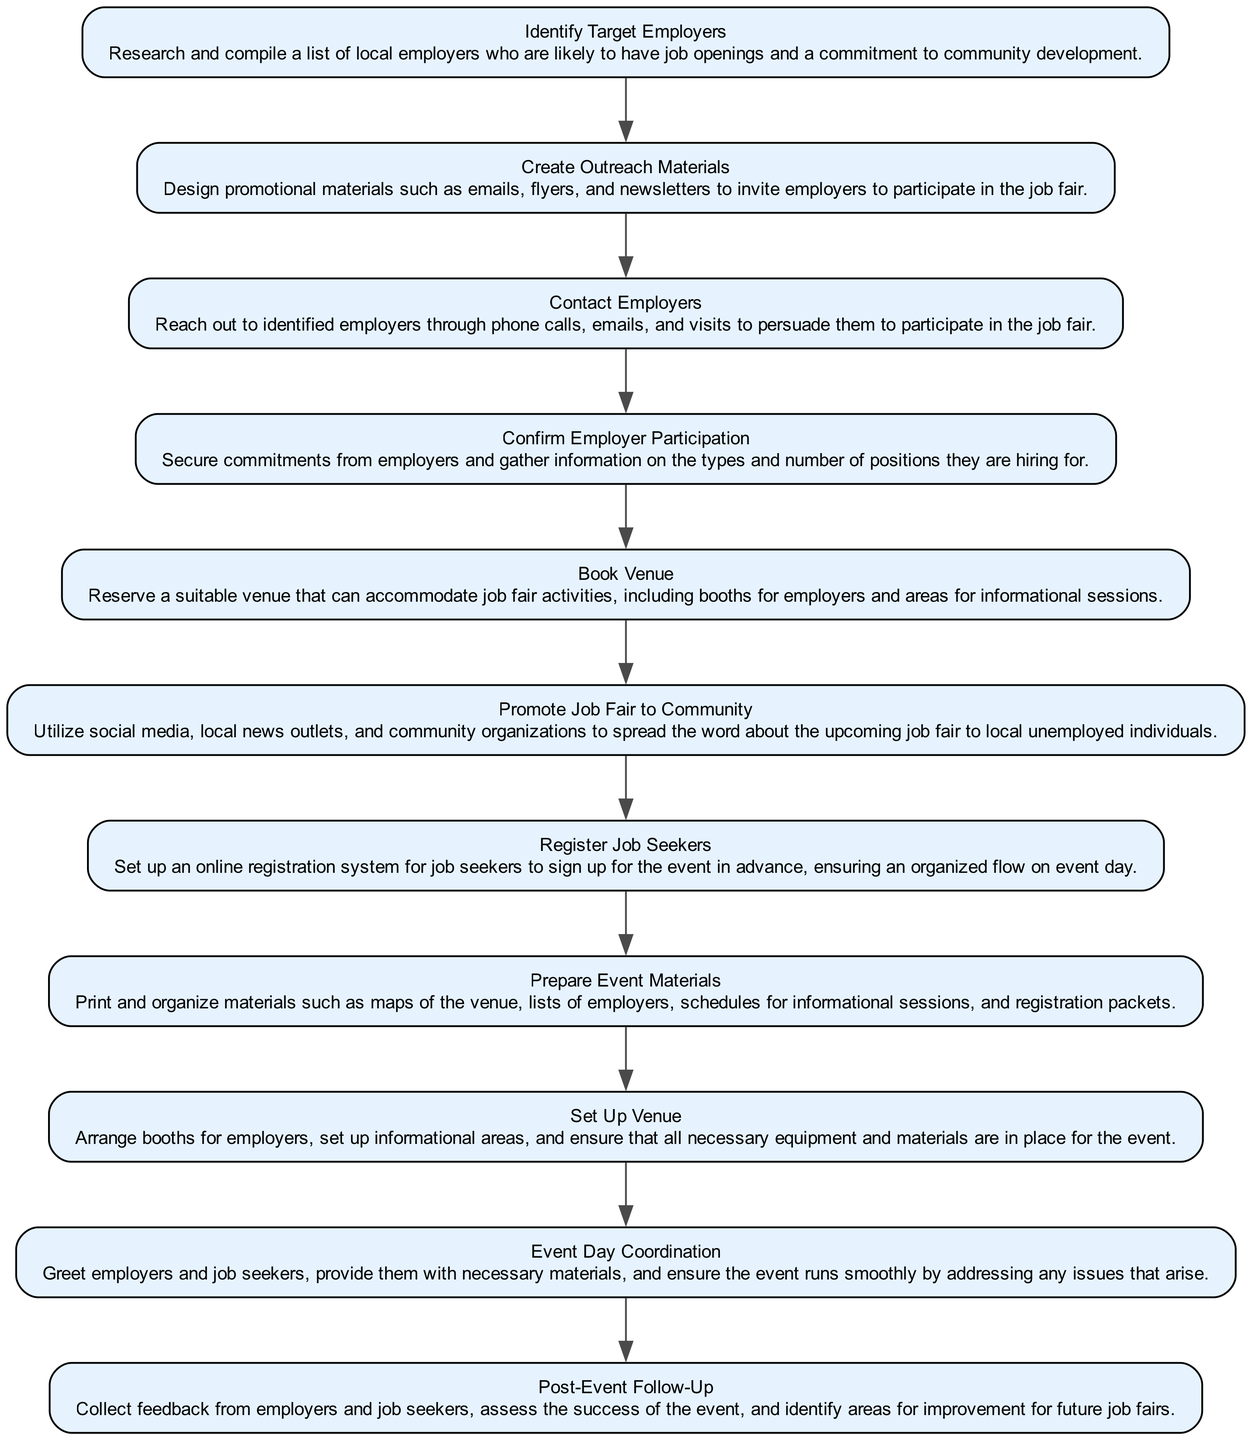What is the first activity in the diagram? The diagram begins with the first activity labeled "Identify Target Employers". As it is the starting point, there are no preceding activities.
Answer: Identify Target Employers What is the last activity shown in the diagram? The last activity listed in the flow of the diagram is "Post-Event Follow-Up". It comes after "Event Day Coordination" and concludes the process.
Answer: Post-Event Follow-Up How many activities are there in total? The diagram contains a total of 11 activities, ranging from the identification of target employers to the post-event follow-up.
Answer: 11 What activity follows "Book Venue"? The activity that follows "Book Venue" is "Promote Job Fair to Community". This transition is described in the flow of the diagram.
Answer: Promote Job Fair to Community Which two activities are directly linked? The activities "Contact Employers" and "Confirm Employer Participation" are directly linked, as one leads into the other in the workflow.
Answer: Contact Employers and Confirm Employer Participation What is the relationship between "Register Job Seekers" and "Prepare Event Materials"? There is a direct transition from "Register Job Seekers" to "Prepare Event Materials", meaning that the first activity directly influences or leads to the second.
Answer: Direct transition Which activity requires booking a venue to proceed? "Promote Job Fair to Community" requires the completion of "Book Venue" before it can proceed, as outlined in the flow.
Answer: Promote Job Fair to Community The number of transitions in the diagram is? The diagram includes a total of 10 transitions that connect the various activities, showing the flow from one task to the next.
Answer: 10 What does "Event Day Coordination" entail? "Event Day Coordination" involves greeting participants, providing materials, and ensuring that the event runs smoothly by addressing any arising issues.
Answer: Greeting participants, providing materials, ensuring smooth operation 